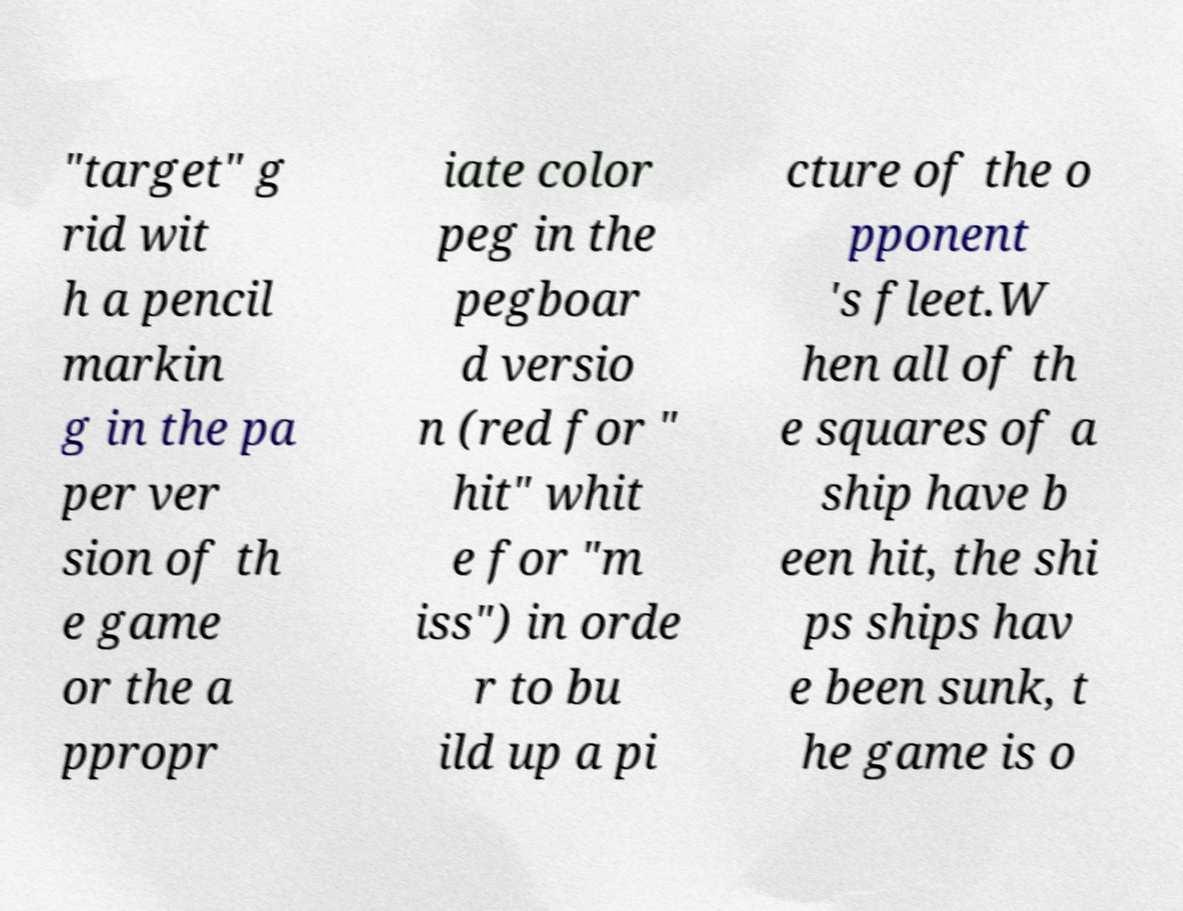Please identify and transcribe the text found in this image. "target" g rid wit h a pencil markin g in the pa per ver sion of th e game or the a ppropr iate color peg in the pegboar d versio n (red for " hit" whit e for "m iss") in orde r to bu ild up a pi cture of the o pponent 's fleet.W hen all of th e squares of a ship have b een hit, the shi ps ships hav e been sunk, t he game is o 